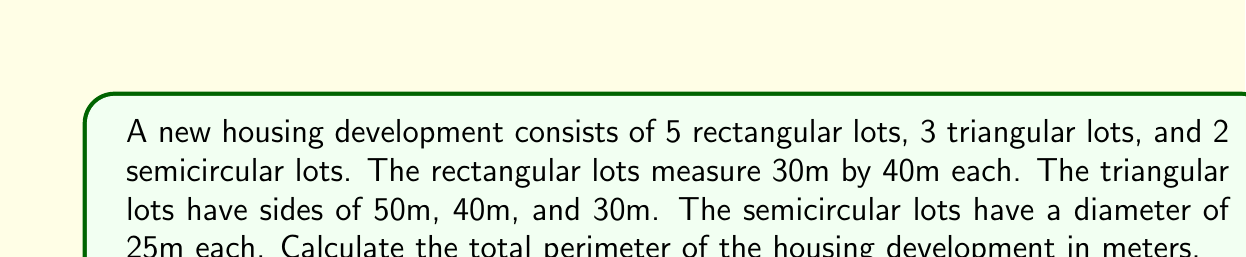Solve this math problem. Let's break this down step-by-step:

1. Rectangular lots:
   - Perimeter of one rectangular lot = $2(l + w) = 2(30 + 40) = 140$ m
   - Total perimeter of 5 rectangular lots = $5 \times 140 = 700$ m

2. Triangular lots:
   - Perimeter of one triangular lot = $50 + 40 + 30 = 120$ m
   - Total perimeter of 3 triangular lots = $3 \times 120 = 360$ m

3. Semicircular lots:
   - Perimeter of one semicircular lot = $\pi r + d = \frac{\pi \times 25}{2} + 25$
   - $= 12.5\pi + 25$ m
   - Total perimeter of 2 semicircular lots = $2(12.5\pi + 25) = 25\pi + 50$ m

4. Total perimeter of the housing development:
   $$\text{Total} = 700 + 360 + (25\pi + 50)$$
   $$= 1110 + 25\pi$$

5. Converting to a decimal approximation:
   $$1110 + 25\pi \approx 1110 + 78.54 \approx 1188.54 \text{ m}$$
Answer: $1110 + 25\pi \approx 1188.54$ m 